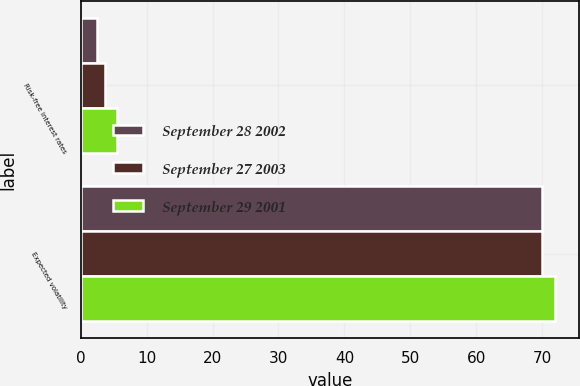Convert chart to OTSL. <chart><loc_0><loc_0><loc_500><loc_500><stacked_bar_chart><ecel><fcel>Risk-free interest rates<fcel>Expected volatility<nl><fcel>September 28 2002<fcel>2.5<fcel>70<nl><fcel>September 27 2003<fcel>3.73<fcel>70<nl><fcel>September 29 2001<fcel>5.5<fcel>72<nl></chart> 